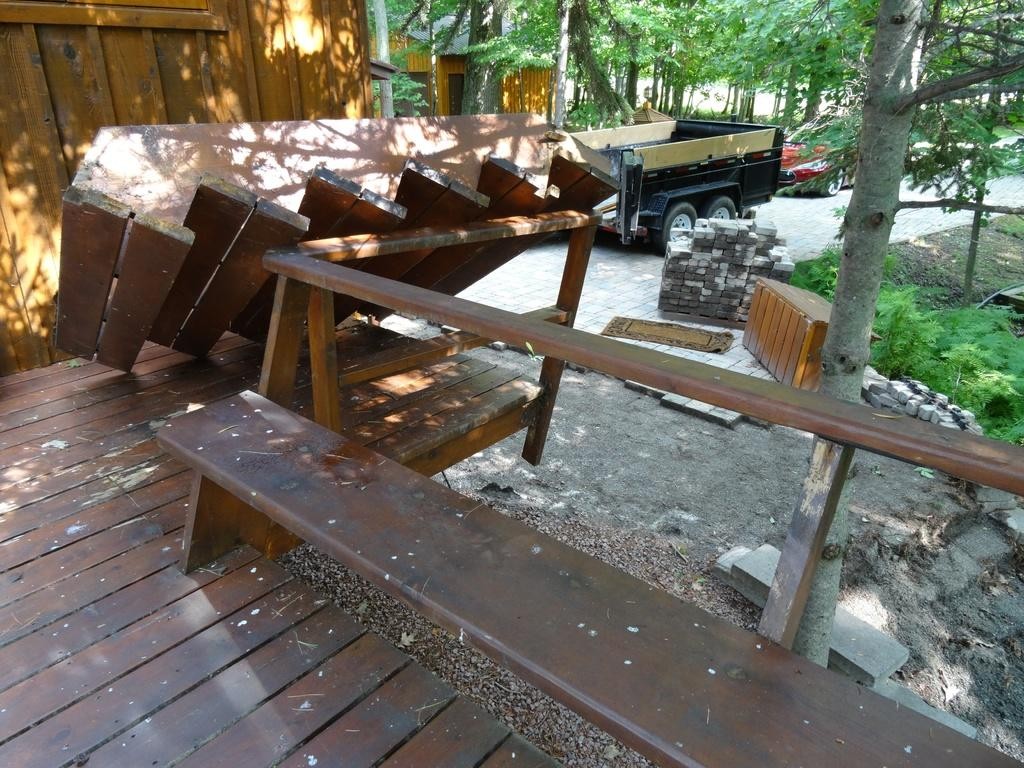What type of seating is visible in the image? There is a bench in the image. What else can be seen in the image besides the bench? There are vehicles and a house visible in the image. What is the surface that the bench, vehicles, and house are resting on? The ground is visible in the image. What type of vegetation is present in the image? There are trees in the image. What type of alarm is ringing in the image? There is no alarm present in the image. How many houses are visible in the image? The image only shows one house. 